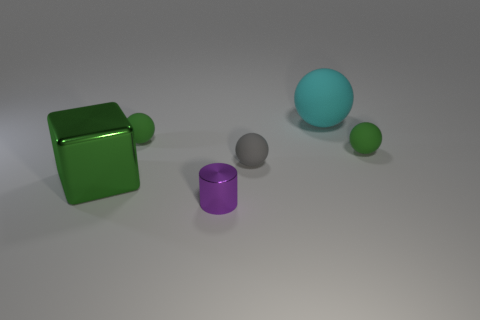Subtract all small spheres. How many spheres are left? 1 Subtract 1 cylinders. How many cylinders are left? 0 Add 2 matte cylinders. How many objects exist? 8 Subtract all gray spheres. How many spheres are left? 3 Subtract all cubes. How many objects are left? 5 Add 6 shiny cubes. How many shiny cubes are left? 7 Add 2 tiny gray metallic objects. How many tiny gray metallic objects exist? 2 Subtract 0 blue cylinders. How many objects are left? 6 Subtract all red balls. Subtract all gray cubes. How many balls are left? 4 Subtract all purple cylinders. How many green balls are left? 2 